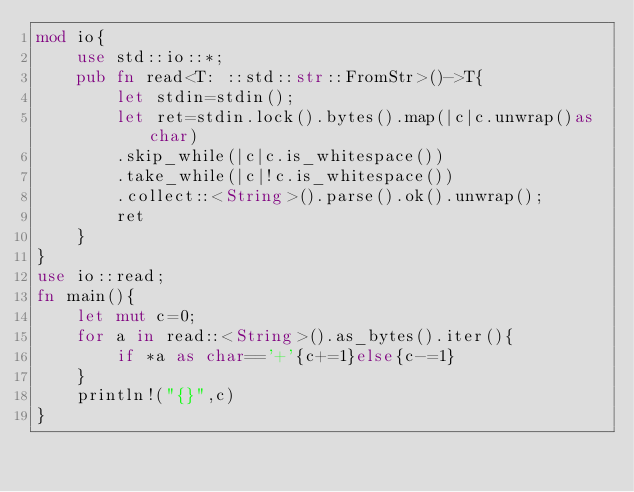<code> <loc_0><loc_0><loc_500><loc_500><_Rust_>mod io{
    use std::io::*;
    pub fn read<T: ::std::str::FromStr>()->T{
        let stdin=stdin();
        let ret=stdin.lock().bytes().map(|c|c.unwrap()as char)
        .skip_while(|c|c.is_whitespace())
        .take_while(|c|!c.is_whitespace())
        .collect::<String>().parse().ok().unwrap();
        ret
    }
}
use io::read;
fn main(){
    let mut c=0;
    for a in read::<String>().as_bytes().iter(){
    	if *a as char=='+'{c+=1}else{c-=1}
    }
    println!("{}",c)
}
</code> 